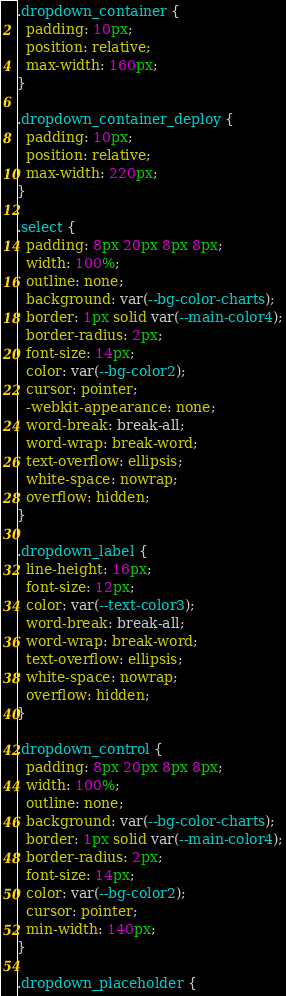Convert code to text. <code><loc_0><loc_0><loc_500><loc_500><_CSS_>.dropdown_container {
  padding: 10px;
  position: relative;
  max-width: 160px;
}

.dropdown_container_deploy {
  padding: 10px;
  position: relative;
  max-width: 220px;
}

.select {
  padding: 8px 20px 8px 8px;
  width: 100%;
  outline: none;
  background: var(--bg-color-charts);
  border: 1px solid var(--main-color4);
  border-radius: 2px;
  font-size: 14px;
  color: var(--bg-color2);
  cursor: pointer;
  -webkit-appearance: none;
  word-break: break-all;
  word-wrap: break-word;
  text-overflow: ellipsis;
  white-space: nowrap;
  overflow: hidden;
}

.dropdown_label {
  line-height: 16px;
  font-size: 12px;
  color: var(--text-color3);
  word-break: break-all;
  word-wrap: break-word;
  text-overflow: ellipsis;
  white-space: nowrap;
  overflow: hidden;
}

.dropdown_control {
  padding: 8px 20px 8px 8px;
  width: 100%;
  outline: none;
  background: var(--bg-color-charts);
  border: 1px solid var(--main-color4);
  border-radius: 2px;
  font-size: 14px;
  color: var(--bg-color2);
  cursor: pointer;
  min-width: 140px;
}

.dropdown_placeholder {</code> 